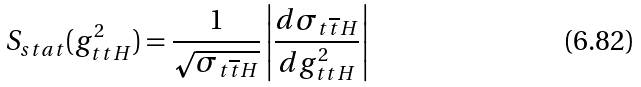<formula> <loc_0><loc_0><loc_500><loc_500>S _ { s t a t } ( g ^ { 2 } _ { t t H } ) = \frac { 1 } { \sqrt { \sigma _ { t \overline { t } H } } } \left | \frac { d \sigma _ { t \overline { t } H } } { d g ^ { 2 } _ { t t H } } \right |</formula> 